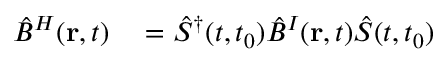Convert formula to latex. <formula><loc_0><loc_0><loc_500><loc_500>\begin{array} { r l } { \hat { B } ^ { H } ( { r } , t ) } & = \hat { S } ^ { \dagger } ( t , t _ { 0 } ) \hat { B } ^ { I } ( { r } , t ) \hat { S } ( t , t _ { 0 } ) } \end{array}</formula> 